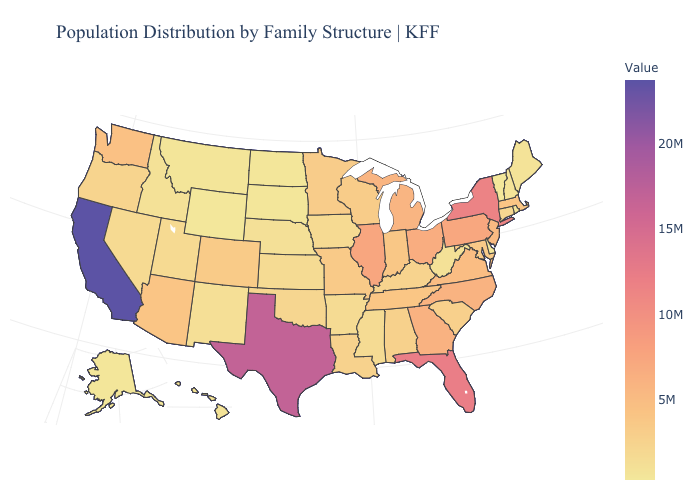Among the states that border South Carolina , which have the highest value?
Quick response, please. Georgia. Among the states that border Minnesota , does South Dakota have the lowest value?
Answer briefly. No. Does Illinois have the highest value in the MidWest?
Concise answer only. Yes. Among the states that border Florida , does Alabama have the highest value?
Concise answer only. No. Which states have the highest value in the USA?
Concise answer only. California. Among the states that border Massachusetts , which have the lowest value?
Keep it brief. Vermont. Which states have the lowest value in the USA?
Concise answer only. Wyoming. 